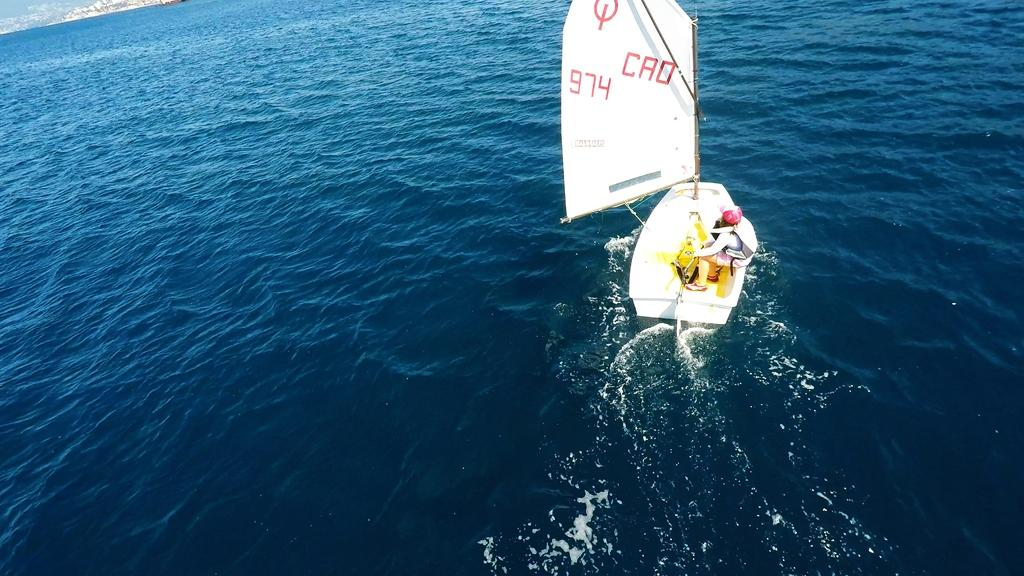What type of vehicle is in the image? There is a white boat in the image. Where is the boat located? The boat is on the water. Is there anyone on the boat? Yes, a person is sitting on the boat. What type of locket is the person wearing on the boat? There is no locket visible on the person in the image. Can you tell me how the boat performs magic tricks on the water? The boat does not perform magic tricks in the image; it is simply a boat on the water. 